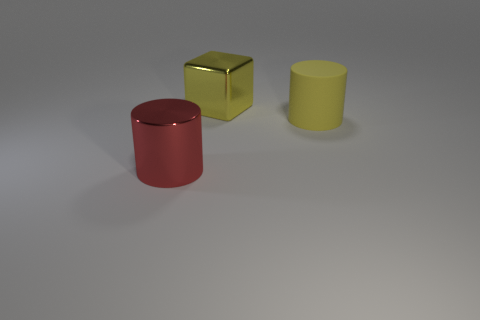Add 2 large red cylinders. How many objects exist? 5 Subtract all cylinders. How many objects are left? 1 Add 1 large red metal cylinders. How many large red metal cylinders are left? 2 Add 1 rubber cylinders. How many rubber cylinders exist? 2 Subtract 1 red cylinders. How many objects are left? 2 Subtract all large red cylinders. Subtract all large yellow matte cubes. How many objects are left? 2 